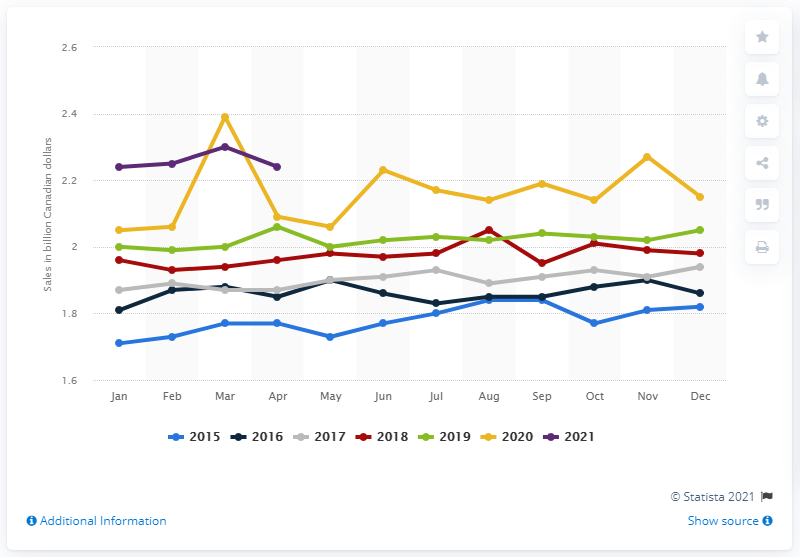Outline some significant characteristics in this image. In April 2021, the retail sales of beer, wine, and liquor stores in Canada reached CAD 2.23 billion. 